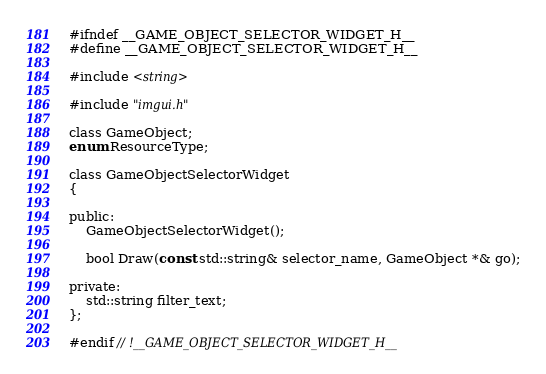Convert code to text. <code><loc_0><loc_0><loc_500><loc_500><_C_>#ifndef __GAME_OBJECT_SELECTOR_WIDGET_H__
#define __GAME_OBJECT_SELECTOR_WIDGET_H__

#include <string>

#include "imgui.h"

class GameObject;
enum ResourceType;

class GameObjectSelectorWidget
{

public:
	GameObjectSelectorWidget();

	bool Draw(const std::string& selector_name, GameObject *& go);

private:
	std::string filter_text;
};

#endif // !__GAME_OBJECT_SELECTOR_WIDGET_H__</code> 